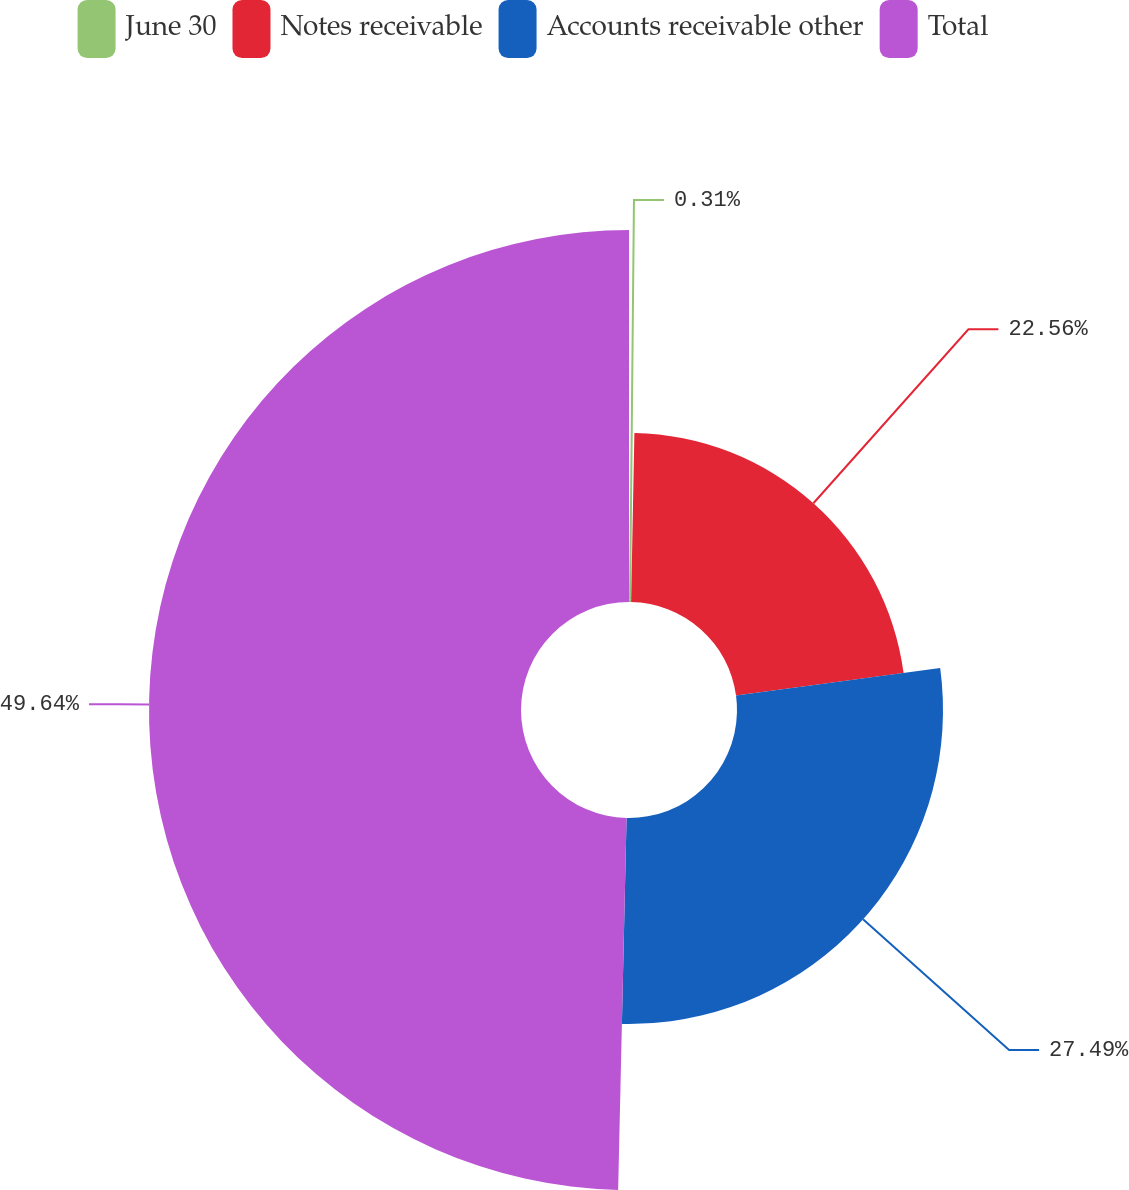Convert chart. <chart><loc_0><loc_0><loc_500><loc_500><pie_chart><fcel>June 30<fcel>Notes receivable<fcel>Accounts receivable other<fcel>Total<nl><fcel>0.31%<fcel>22.56%<fcel>27.49%<fcel>49.64%<nl></chart> 